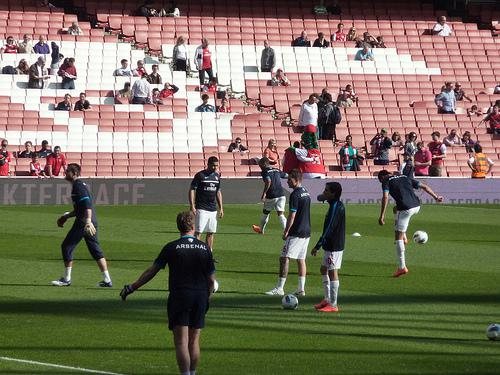Question: who is playing?
Choices:
A. A women's team.
B. A mens' team.
C. The children.
D. The senior citizens.
Answer with the letter. Answer: B Question: what sport are they playing?
Choices:
A. Football.
B. Baseball.
C. Tennis.
D. Soccer.
Answer with the letter. Answer: D Question: who is in the seats?
Choices:
A. Parents.
B. Team members.
C. Spectators.
D. Teachers.
Answer with the letter. Answer: C Question: where are they playing?
Choices:
A. At a stadium.
B. At the baseball field.
C. At the tennis courts.
D. At the pool.
Answer with the letter. Answer: A 